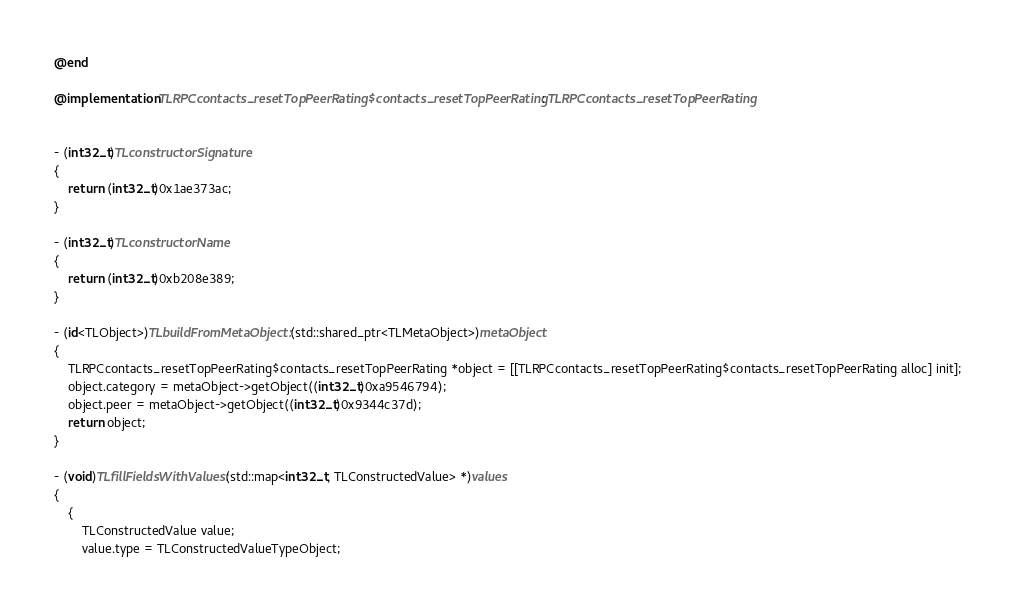<code> <loc_0><loc_0><loc_500><loc_500><_ObjectiveC_>@end

@implementation TLRPCcontacts_resetTopPeerRating$contacts_resetTopPeerRating : TLRPCcontacts_resetTopPeerRating


- (int32_t)TLconstructorSignature
{
    return (int32_t)0x1ae373ac;
}

- (int32_t)TLconstructorName
{
    return (int32_t)0xb208e389;
}

- (id<TLObject>)TLbuildFromMetaObject:(std::shared_ptr<TLMetaObject>)metaObject
{
    TLRPCcontacts_resetTopPeerRating$contacts_resetTopPeerRating *object = [[TLRPCcontacts_resetTopPeerRating$contacts_resetTopPeerRating alloc] init];
    object.category = metaObject->getObject((int32_t)0xa9546794);
    object.peer = metaObject->getObject((int32_t)0x9344c37d);
    return object;
}

- (void)TLfillFieldsWithValues:(std::map<int32_t, TLConstructedValue> *)values
{
    {
        TLConstructedValue value;
        value.type = TLConstructedValueTypeObject;</code> 